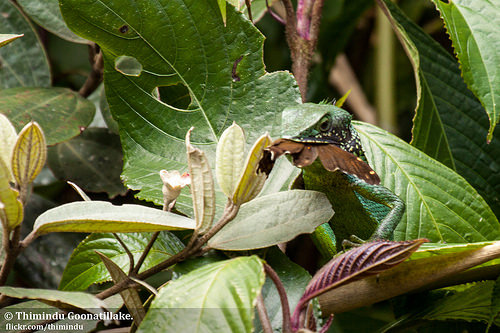<image>
Is the chameleon behind the leaf? No. The chameleon is not behind the leaf. From this viewpoint, the chameleon appears to be positioned elsewhere in the scene. 